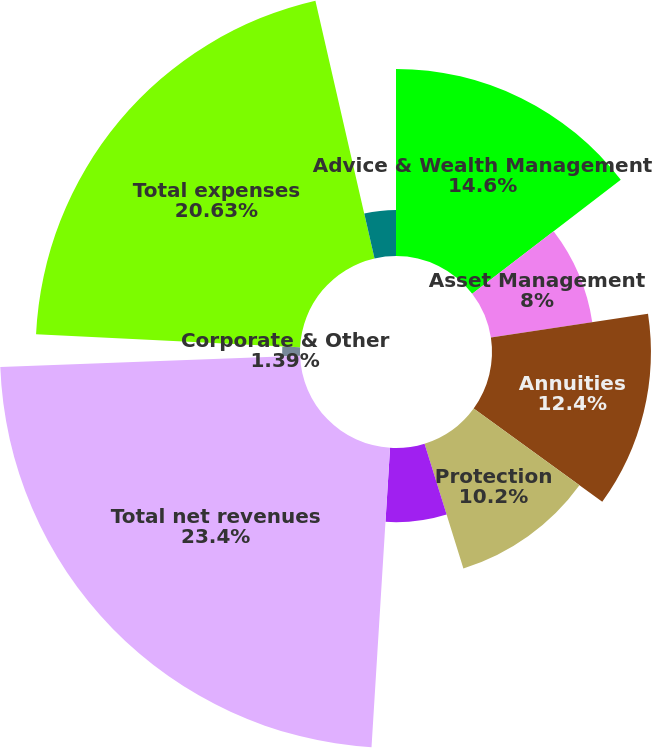<chart> <loc_0><loc_0><loc_500><loc_500><pie_chart><fcel>Advice & Wealth Management<fcel>Asset Management<fcel>Annuities<fcel>Protection<fcel>Eliminations<fcel>Total net revenues<fcel>Corporate & Other<fcel>Total expenses<fcel>Pretax income<nl><fcel>14.6%<fcel>8.0%<fcel>12.4%<fcel>10.2%<fcel>5.79%<fcel>23.41%<fcel>1.39%<fcel>20.63%<fcel>3.59%<nl></chart> 